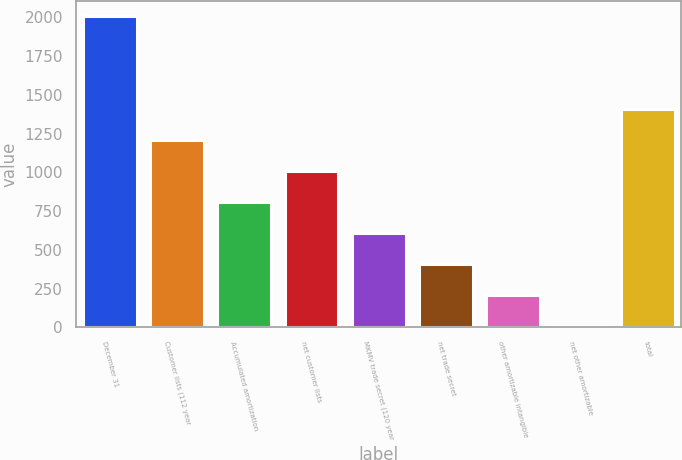Convert chart. <chart><loc_0><loc_0><loc_500><loc_500><bar_chart><fcel>December 31<fcel>Customer lists (112 year<fcel>Accumulated amortization<fcel>net customer lists<fcel>MKMV trade secret (120 year<fcel>net trade secret<fcel>other amortizable intangible<fcel>net other amortizable<fcel>total<nl><fcel>2006<fcel>1206.32<fcel>806.48<fcel>1006.4<fcel>606.56<fcel>406.64<fcel>206.72<fcel>6.8<fcel>1406.24<nl></chart> 